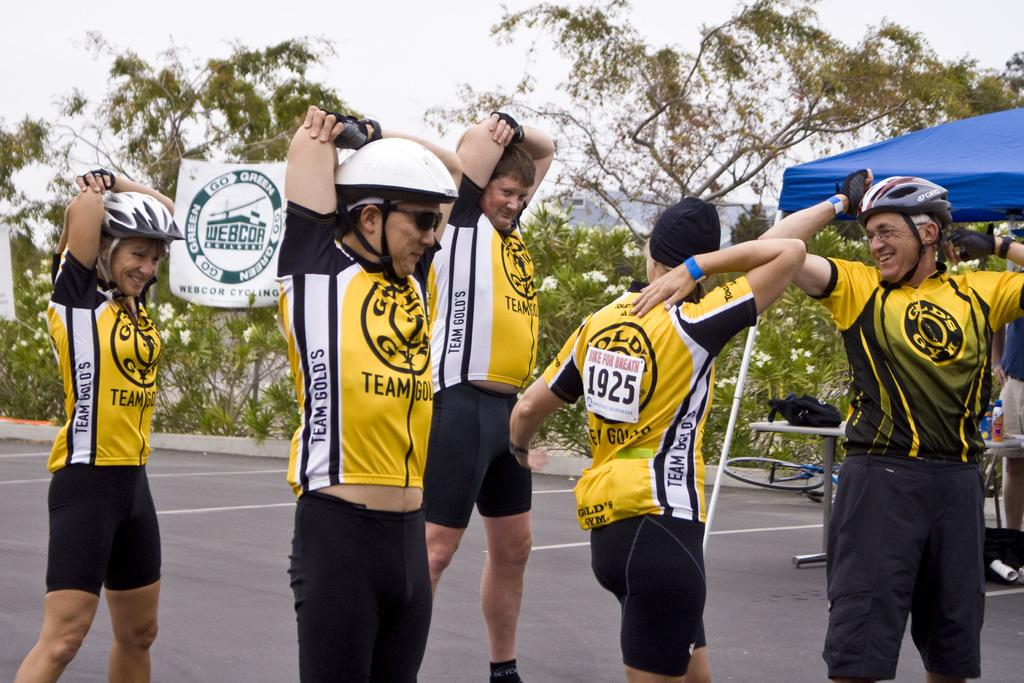<image>
Summarize the visual content of the image. A man with number 1925 is stretching with his team. 